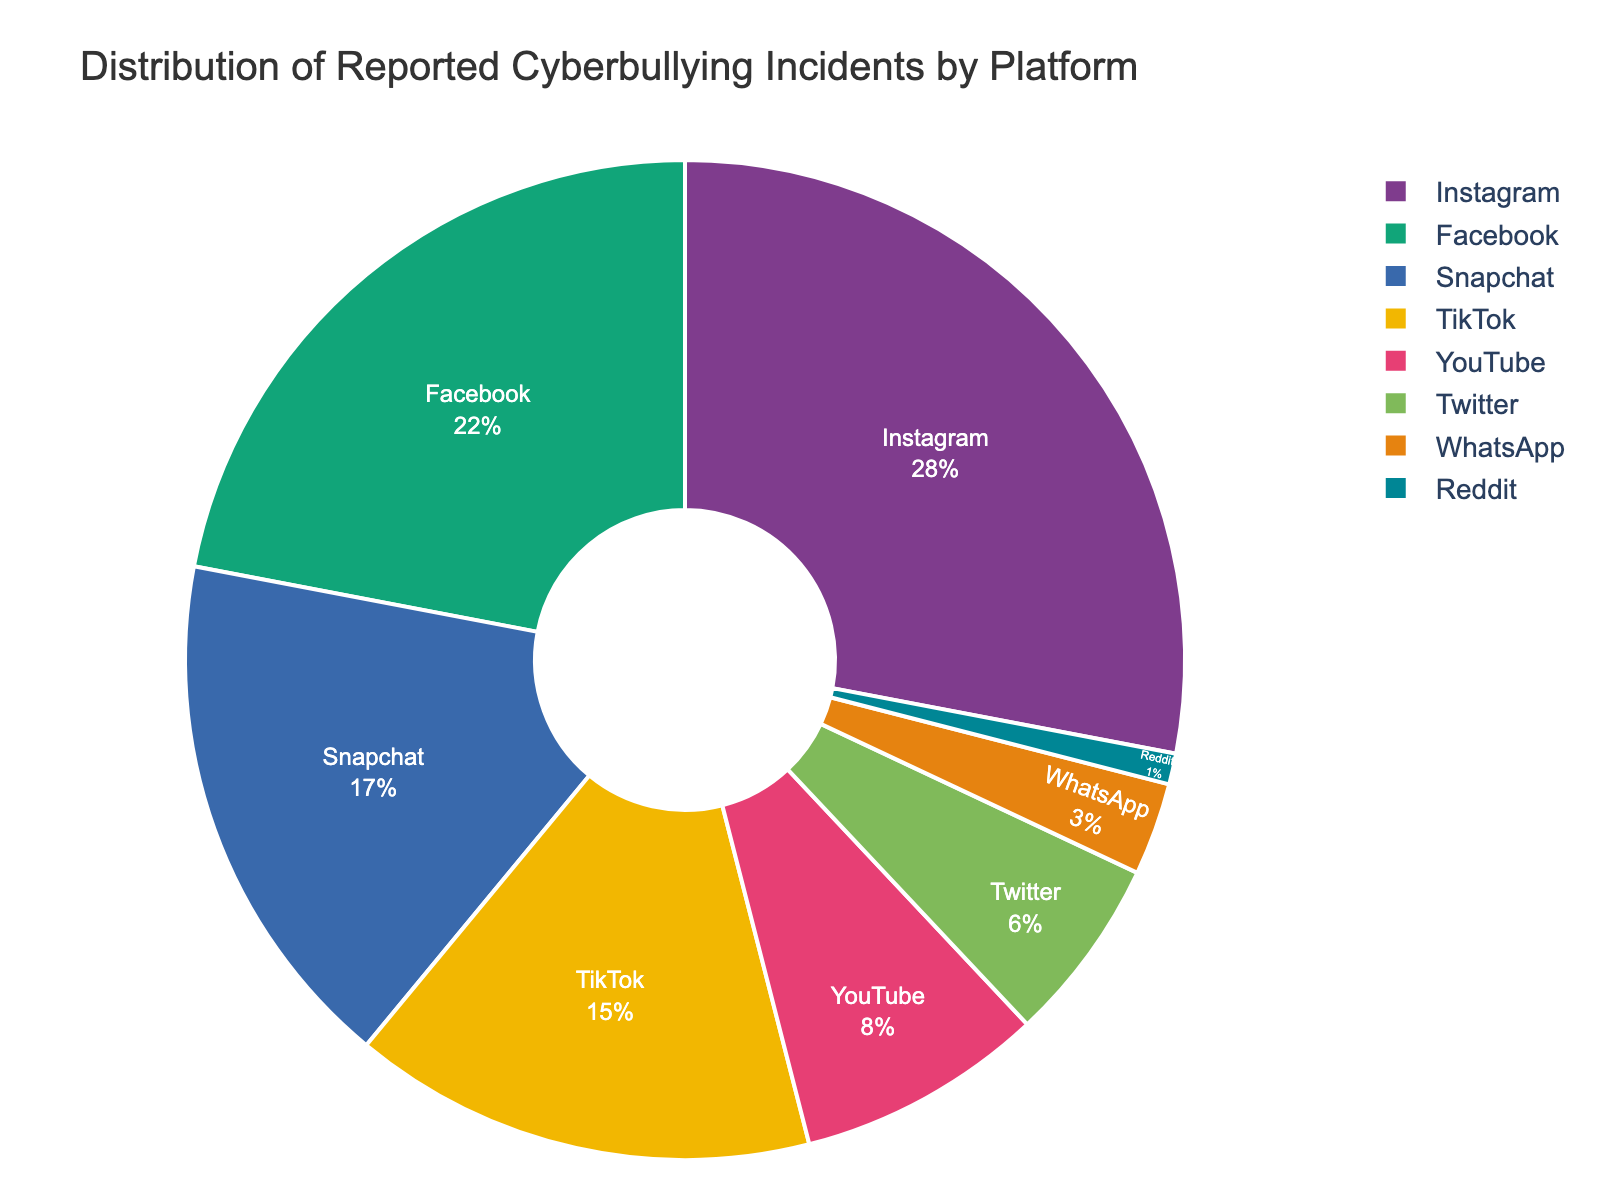What percentage of cyberbullying incidents were reported on Instagram? To find out the percentage of cyberbullying incidents reported on Instagram, look at the section of the pie chart labeled "Instagram." The percentage value inside this segment will give the answer.
Answer: 28% Which platform has the least reported cyberbullying incidents? To determine the platform with the least reported cyberbullying incidents, identify the smallest segment in the pie chart. The platform label within this segment will indicate the correct answer.
Answer: Reddit What is the combined percentage of cyberbullying incidents reported on Instagram and Facebook? To find the combined percentage, identify the percentages for Instagram and Facebook from the pie chart. Then, add these two percentages together. So, it's 28% (Instagram) + 22% (Facebook).
Answer: 50% Is the percentage of incidents reported on Snapchat greater than those reported on TikTok? Compare the percentage values provided for Snapchat and TikTok from the pie chart. If Snapchat's percentage is higher, then it is greater. Snapchat has 17% whereas TikTok has 15%, so yes, it is greater.
Answer: Yes What is the total percentage of reported incidents for platforms with less than 10% each? Identify platforms with percentages less than 10% from the pie chart: YouTube (8%), Twitter (6%), WhatsApp (3%), and Reddit (1%). Sum these percentages to get the total. 8% + 6% + 3% + 1% = 18%.
Answer: 18% How much more percentage of incidents are reported on Facebook compared to Twitter? To find the difference in percentages of incidents between Facebook and Twitter, subtract Twitter's percentage from Facebook's. 22% - 6% = 16%.
Answer: 16% Which platform has roughly half the reported incidents of Instagram? To find which platform has about half the incidents of Instagram, look for a platform with a percentage close to half of 28%. Facebook has 22%, which is the closest to half of Instagram's 28%.
Answer: Facebook Rank the platforms from highest to lowest reported incidents. Identify the percentages and their corresponding platforms from the pie chart, then sort them from highest to lowest percentage. The order is:
1. Instagram (28%)
2. Facebook (22%)
3. Snapchat (17%)
4. TikTok (15%)
5. YouTube (8%)
6. Twitter (6%)
7. WhatsApp (3%)
8. Reddit (1%)
Answer: Instagram > Facebook > Snapchat > TikTok > YouTube > Twitter > WhatsApp > Reddit What is the difference between the combined percentage of Snapchat and TikTok and the combined percentage of YouTube and Twitter? First, add the percentages for Snapchat (17%) and TikTok (15%): 17% + 15% = 32%. Then, add the percentages for YouTube (8%) and Twitter (6%): 8% + 6% = 14%. Subtract the smaller sum from the larger sum: 32% - 14% = 18%.
Answer: 18% Is the percentage of incidents reported on Reddit less than one-tenth of those reported on Snapchat? Look at the percentages given in the pie chart for Reddit and Snapchat. One-tenth of Snapchat's incidents is 17% / 10 = 1.7%. Since Reddit's percentage is 1%, which is less than 1.7%, the statement is true.
Answer: Yes 